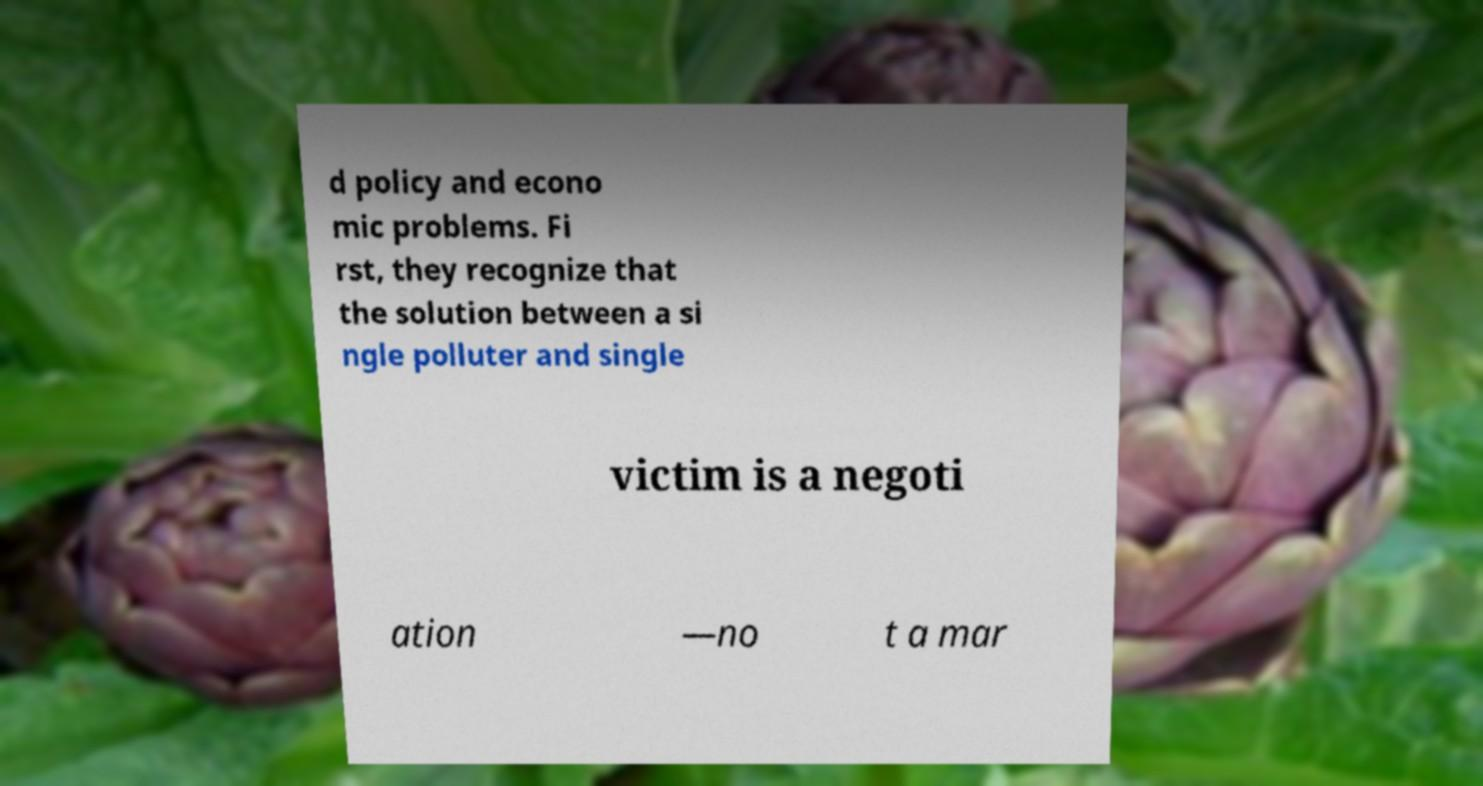Please identify and transcribe the text found in this image. d policy and econo mic problems. Fi rst, they recognize that the solution between a si ngle polluter and single victim is a negoti ation —no t a mar 